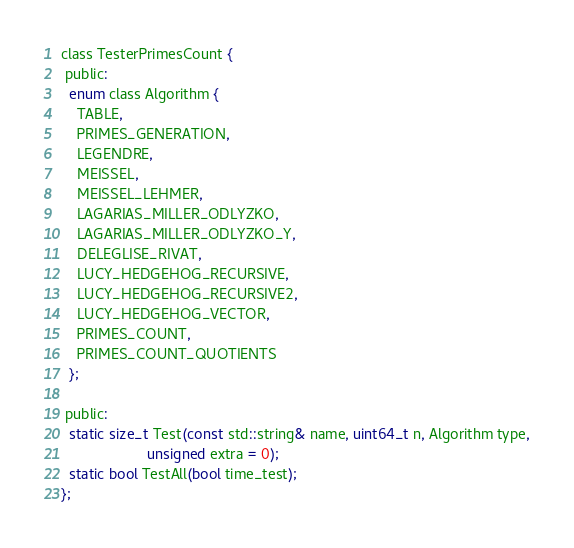Convert code to text. <code><loc_0><loc_0><loc_500><loc_500><_C_>
class TesterPrimesCount {
 public:
  enum class Algorithm {
    TABLE,
    PRIMES_GENERATION,
    LEGENDRE,
    MEISSEL,
    MEISSEL_LEHMER,
    LAGARIAS_MILLER_ODLYZKO,
    LAGARIAS_MILLER_ODLYZKO_Y,
    DELEGLISE_RIVAT,
    LUCY_HEDGEHOG_RECURSIVE,
    LUCY_HEDGEHOG_RECURSIVE2,
    LUCY_HEDGEHOG_VECTOR,
    PRIMES_COUNT,
    PRIMES_COUNT_QUOTIENTS
  };

 public:
  static size_t Test(const std::string& name, uint64_t n, Algorithm type,
                     unsigned extra = 0);
  static bool TestAll(bool time_test);
};
</code> 